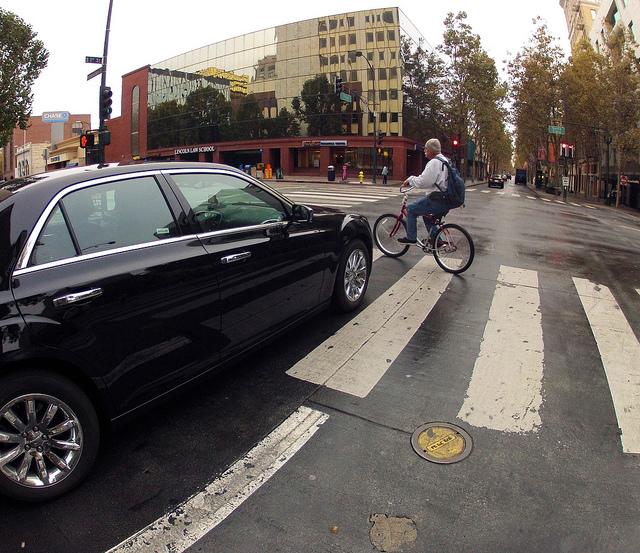Did this car stop in a hurry?
Short answer required. Yes. What is on the man's head?
Quick response, please. Hat. Why is the car stopped?
Give a very brief answer. Let bike pass. 